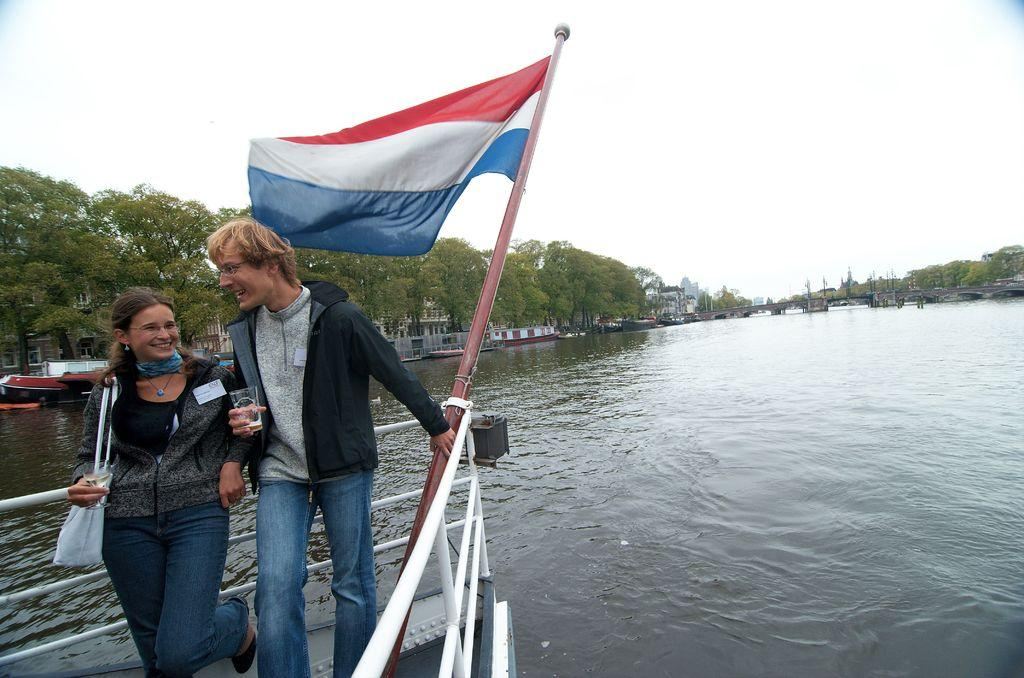What is the main subject of the image? The main subject of the image is a ship. Where is the ship located? The ship is on a river. What can be seen in the image besides the ship? There is a couple standing in the image, and they are smiling. What is visible in the background of the image? There are buildings and trees in the background of the image. What type of bone can be seen in the image? There is no bone present in the image. What is the reason for the ship's engine failure in the image? There is no indication of an engine failure in the image, as the ship is on a river and appears to be functioning normally. 